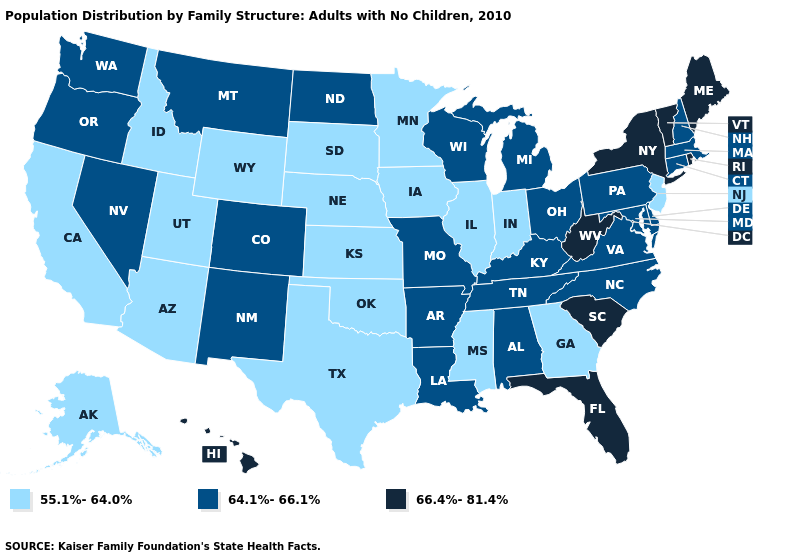What is the value of Kansas?
Write a very short answer. 55.1%-64.0%. How many symbols are there in the legend?
Be succinct. 3. What is the value of South Carolina?
Concise answer only. 66.4%-81.4%. What is the highest value in the South ?
Keep it brief. 66.4%-81.4%. What is the value of New York?
Give a very brief answer. 66.4%-81.4%. Among the states that border Vermont , which have the highest value?
Answer briefly. New York. Does Kentucky have the lowest value in the USA?
Answer briefly. No. What is the lowest value in states that border California?
Quick response, please. 55.1%-64.0%. What is the highest value in the USA?
Short answer required. 66.4%-81.4%. Name the states that have a value in the range 64.1%-66.1%?
Quick response, please. Alabama, Arkansas, Colorado, Connecticut, Delaware, Kentucky, Louisiana, Maryland, Massachusetts, Michigan, Missouri, Montana, Nevada, New Hampshire, New Mexico, North Carolina, North Dakota, Ohio, Oregon, Pennsylvania, Tennessee, Virginia, Washington, Wisconsin. Name the states that have a value in the range 64.1%-66.1%?
Concise answer only. Alabama, Arkansas, Colorado, Connecticut, Delaware, Kentucky, Louisiana, Maryland, Massachusetts, Michigan, Missouri, Montana, Nevada, New Hampshire, New Mexico, North Carolina, North Dakota, Ohio, Oregon, Pennsylvania, Tennessee, Virginia, Washington, Wisconsin. What is the value of New York?
Write a very short answer. 66.4%-81.4%. Name the states that have a value in the range 66.4%-81.4%?
Keep it brief. Florida, Hawaii, Maine, New York, Rhode Island, South Carolina, Vermont, West Virginia. Does New Mexico have a higher value than Maryland?
Keep it brief. No. 